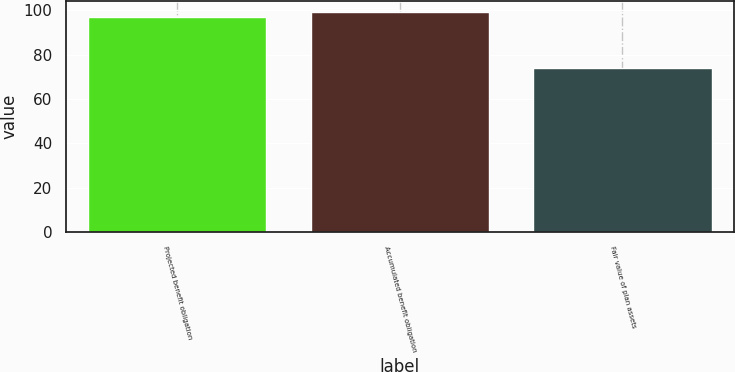Convert chart. <chart><loc_0><loc_0><loc_500><loc_500><bar_chart><fcel>Projected benefit obligation<fcel>Accumulated benefit obligation<fcel>Fair value of plan assets<nl><fcel>97<fcel>99.3<fcel>74<nl></chart> 